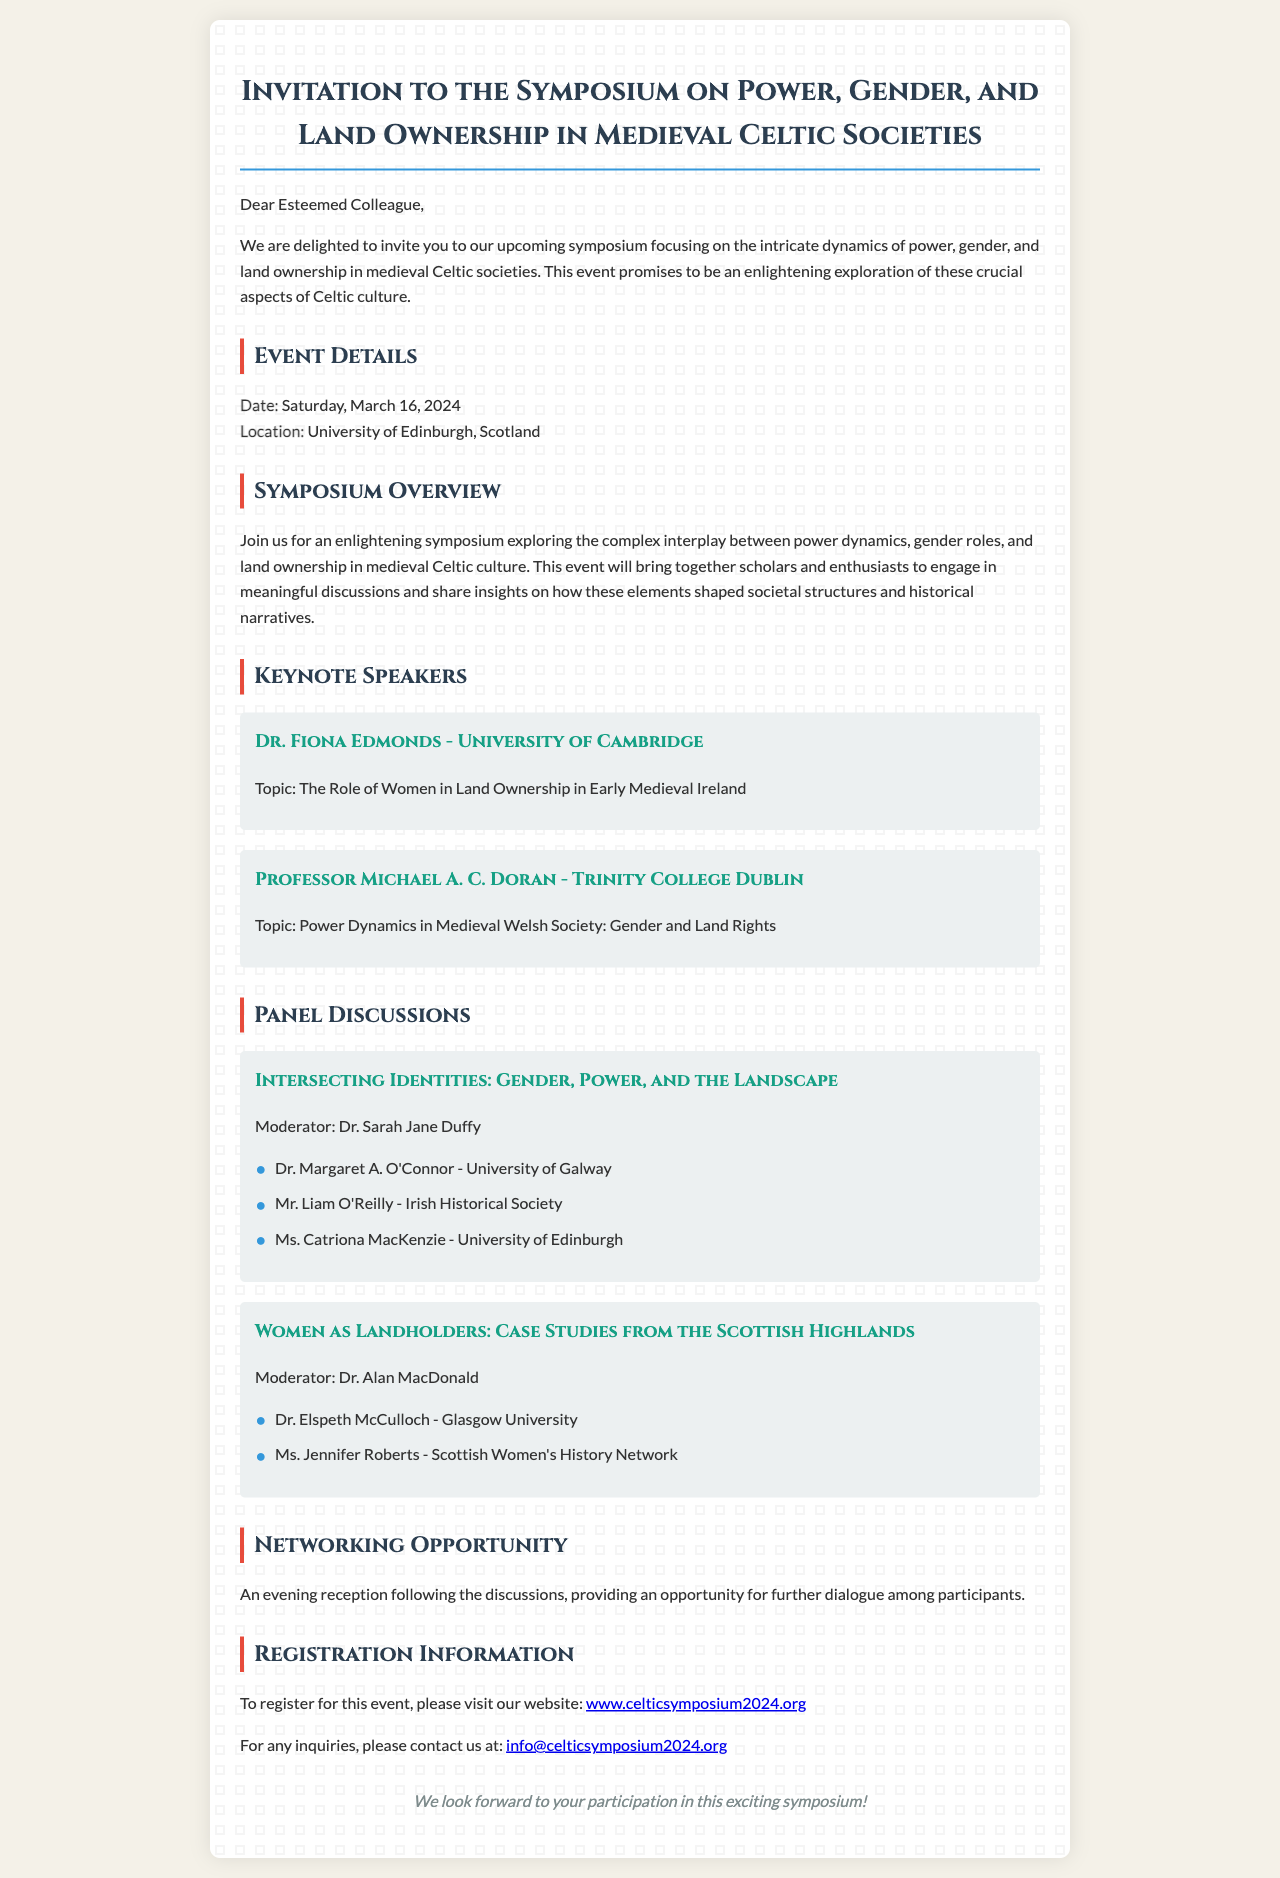What is the date of the symposium? The date of the symposium is explicitly mentioned in the document as March 16, 2024.
Answer: March 16, 2024 Who is the moderator for the first panel discussion? The document specifies that Dr. Sarah Jane Duffy is the moderator for the discussion titled "Intersecting Identities: Gender, Power, and the Landscape."
Answer: Dr. Sarah Jane Duffy What university is Dr. Fiona Edmonds affiliated with? The document states that Dr. Fiona Edmonds is affiliated with the University of Cambridge.
Answer: University of Cambridge What topic will Professor Michael A. C. Doran address? The document outlines that Professor Michael A. C. Doran will discuss "Power Dynamics in Medieval Welsh Society: Gender and Land Rights."
Answer: Power Dynamics in Medieval Welsh Society: Gender and Land Rights How many keynote speakers are mentioned in the document? The document lists two keynote speakers, Dr. Fiona Edmonds and Professor Michael A. C. Doran.
Answer: Two What opportunity is provided after the panel discussions? The document indicates there will be an evening reception following the discussions for further dialogue.
Answer: Evening reception What is the website for registration? The website for registration is clearly stated in the document as www.celticsymposium2024.org.
Answer: www.celticsymposium2024.org What is the location of the symposium? The document specifies that the symposium will take place at the University of Edinburgh, Scotland.
Answer: University of Edinburgh, Scotland 